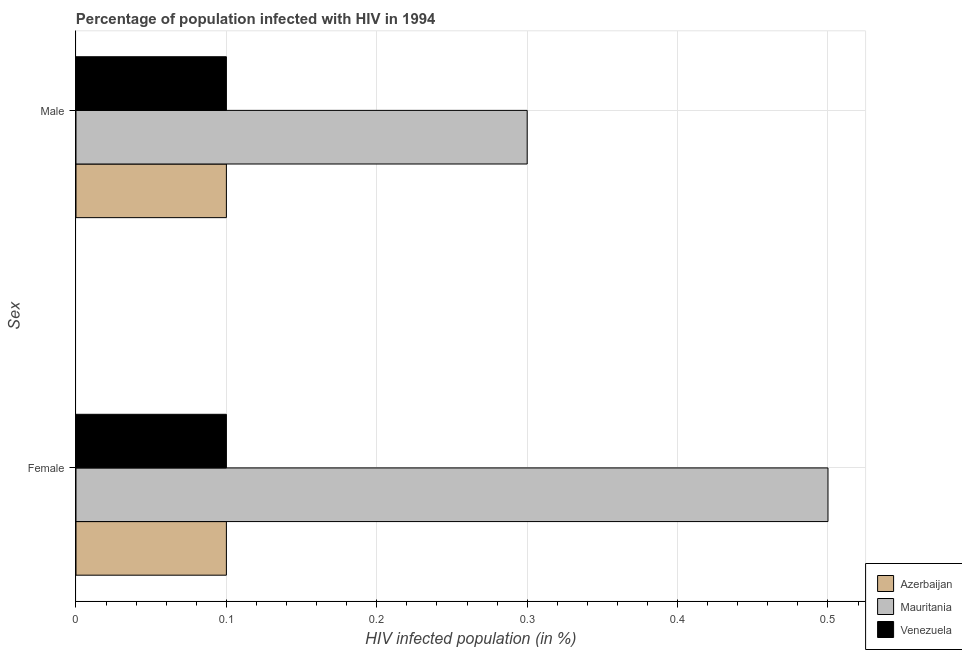How many different coloured bars are there?
Offer a very short reply. 3. How many groups of bars are there?
Offer a very short reply. 2. Are the number of bars on each tick of the Y-axis equal?
Offer a very short reply. Yes. How many bars are there on the 2nd tick from the bottom?
Give a very brief answer. 3. Across all countries, what is the minimum percentage of females who are infected with hiv?
Give a very brief answer. 0.1. In which country was the percentage of males who are infected with hiv maximum?
Ensure brevity in your answer.  Mauritania. In which country was the percentage of females who are infected with hiv minimum?
Your answer should be very brief. Azerbaijan. What is the difference between the percentage of males who are infected with hiv in Venezuela and that in Azerbaijan?
Your answer should be compact. 0. What is the difference between the percentage of males who are infected with hiv in Mauritania and the percentage of females who are infected with hiv in Venezuela?
Ensure brevity in your answer.  0.2. What is the average percentage of males who are infected with hiv per country?
Keep it short and to the point. 0.17. What is the difference between the percentage of females who are infected with hiv and percentage of males who are infected with hiv in Venezuela?
Make the answer very short. 0. In how many countries, is the percentage of females who are infected with hiv greater than 0.08 %?
Give a very brief answer. 3. What is the ratio of the percentage of males who are infected with hiv in Azerbaijan to that in Mauritania?
Keep it short and to the point. 0.33. What does the 3rd bar from the top in Female represents?
Your answer should be compact. Azerbaijan. What does the 3rd bar from the bottom in Male represents?
Your answer should be very brief. Venezuela. Are all the bars in the graph horizontal?
Offer a terse response. Yes. How many countries are there in the graph?
Keep it short and to the point. 3. What is the difference between two consecutive major ticks on the X-axis?
Offer a very short reply. 0.1. Are the values on the major ticks of X-axis written in scientific E-notation?
Provide a succinct answer. No. Does the graph contain grids?
Your answer should be compact. Yes. How many legend labels are there?
Offer a terse response. 3. What is the title of the graph?
Keep it short and to the point. Percentage of population infected with HIV in 1994. Does "Vietnam" appear as one of the legend labels in the graph?
Keep it short and to the point. No. What is the label or title of the X-axis?
Offer a very short reply. HIV infected population (in %). What is the label or title of the Y-axis?
Your answer should be very brief. Sex. What is the HIV infected population (in %) in Azerbaijan in Female?
Make the answer very short. 0.1. What is the HIV infected population (in %) of Mauritania in Female?
Offer a terse response. 0.5. What is the HIV infected population (in %) of Venezuela in Female?
Provide a succinct answer. 0.1. What is the HIV infected population (in %) in Azerbaijan in Male?
Make the answer very short. 0.1. What is the HIV infected population (in %) of Venezuela in Male?
Offer a terse response. 0.1. Across all Sex, what is the maximum HIV infected population (in %) of Mauritania?
Offer a very short reply. 0.5. Across all Sex, what is the minimum HIV infected population (in %) in Venezuela?
Your answer should be compact. 0.1. What is the difference between the HIV infected population (in %) in Azerbaijan in Female and the HIV infected population (in %) in Mauritania in Male?
Your answer should be compact. -0.2. What is the difference between the HIV infected population (in %) in Mauritania in Female and the HIV infected population (in %) in Venezuela in Male?
Your answer should be very brief. 0.4. What is the average HIV infected population (in %) in Azerbaijan per Sex?
Your answer should be compact. 0.1. What is the average HIV infected population (in %) of Mauritania per Sex?
Make the answer very short. 0.4. What is the difference between the HIV infected population (in %) of Azerbaijan and HIV infected population (in %) of Venezuela in Male?
Your response must be concise. 0. What is the difference between the HIV infected population (in %) of Mauritania and HIV infected population (in %) of Venezuela in Male?
Offer a very short reply. 0.2. What is the ratio of the HIV infected population (in %) in Azerbaijan in Female to that in Male?
Give a very brief answer. 1. What is the ratio of the HIV infected population (in %) of Venezuela in Female to that in Male?
Your response must be concise. 1. What is the difference between the highest and the second highest HIV infected population (in %) of Azerbaijan?
Ensure brevity in your answer.  0. What is the difference between the highest and the second highest HIV infected population (in %) in Venezuela?
Your answer should be very brief. 0. What is the difference between the highest and the lowest HIV infected population (in %) of Azerbaijan?
Ensure brevity in your answer.  0. What is the difference between the highest and the lowest HIV infected population (in %) of Mauritania?
Offer a very short reply. 0.2. What is the difference between the highest and the lowest HIV infected population (in %) in Venezuela?
Offer a terse response. 0. 